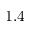Convert formula to latex. <formula><loc_0><loc_0><loc_500><loc_500>1 . 4</formula> 